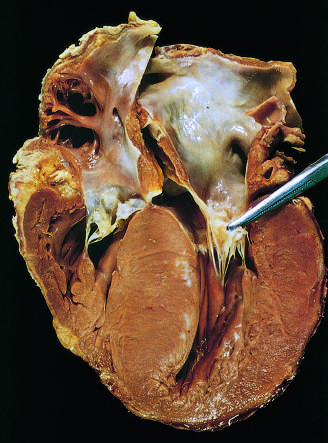has the anterior mitral leaflet been moved away from the septum to reveal a fibrous endocardial plaque see text?
Answer the question using a single word or phrase. Yes 